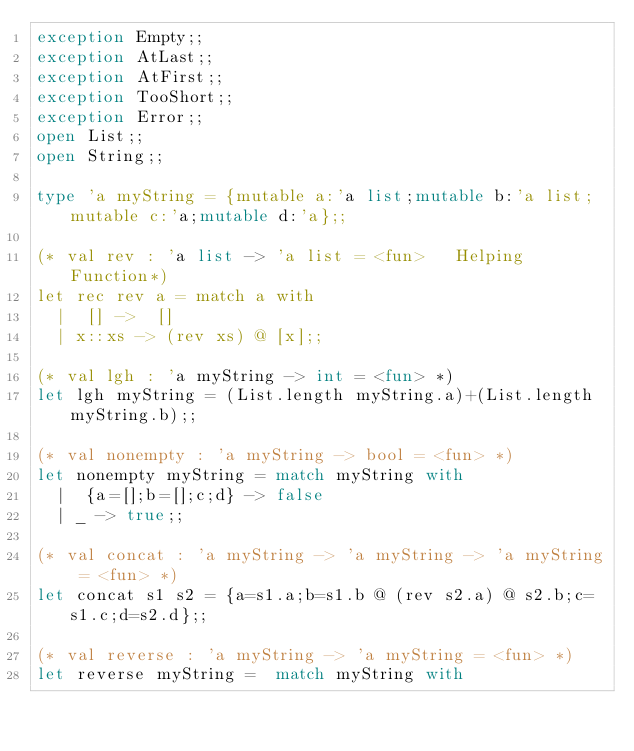<code> <loc_0><loc_0><loc_500><loc_500><_OCaml_>exception Empty;;
exception AtLast;;
exception AtFirst;;
exception TooShort;;
exception Error;;
open List;;
open String;;

type 'a myString = {mutable a:'a list;mutable b:'a list;mutable c:'a;mutable d:'a};;

(* val rev : 'a list -> 'a list = <fun>   Helping Function*)
let rec rev a = match a with
  |  [] ->  []
  | x::xs -> (rev xs) @ [x];;

(* val lgh : 'a myString -> int = <fun> *)
let lgh myString = (List.length myString.a)+(List.length myString.b);;

(* val nonempty : 'a myString -> bool = <fun> *)
let nonempty myString = match myString with
  |  {a=[];b=[];c;d} -> false
  | _ -> true;;

(* val concat : 'a myString -> 'a myString -> 'a myString = <fun> *)
let concat s1 s2 = {a=s1.a;b=s1.b @ (rev s2.a) @ s2.b;c=s1.c;d=s2.d};;

(* val reverse : 'a myString -> 'a myString = <fun> *)
let reverse myString =  match myString with</code> 